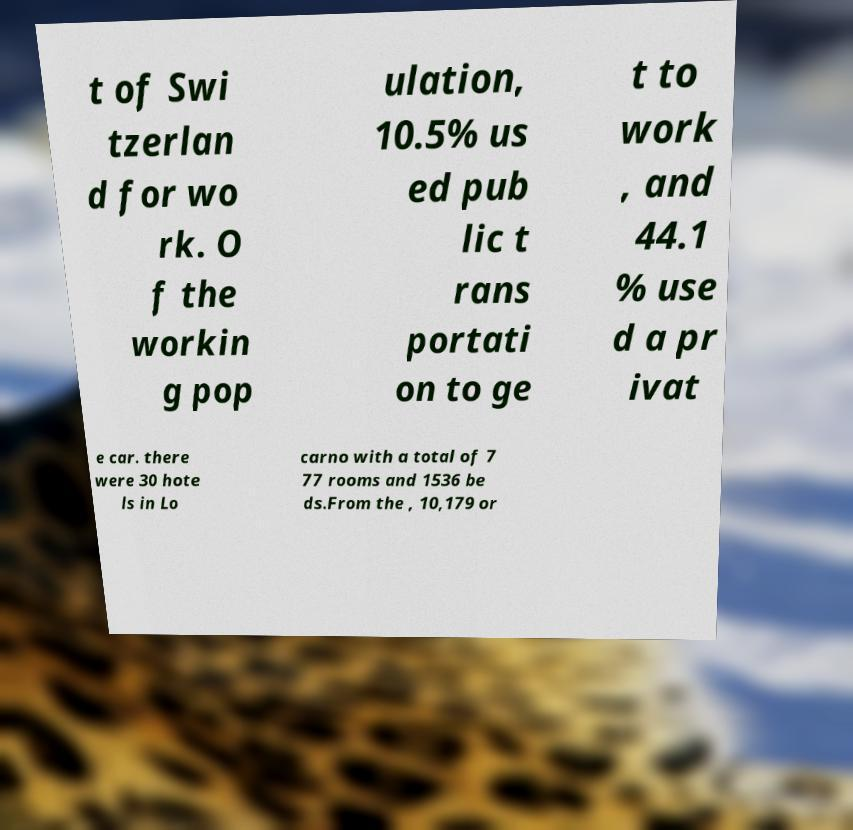Could you assist in decoding the text presented in this image and type it out clearly? t of Swi tzerlan d for wo rk. O f the workin g pop ulation, 10.5% us ed pub lic t rans portati on to ge t to work , and 44.1 % use d a pr ivat e car. there were 30 hote ls in Lo carno with a total of 7 77 rooms and 1536 be ds.From the , 10,179 or 